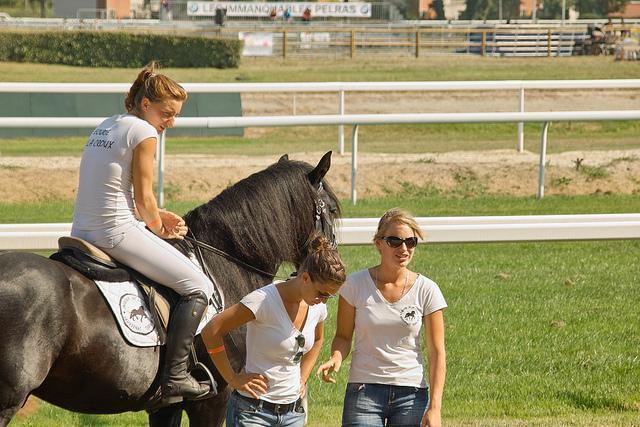How many people are visible?
Give a very brief answer. 3. 